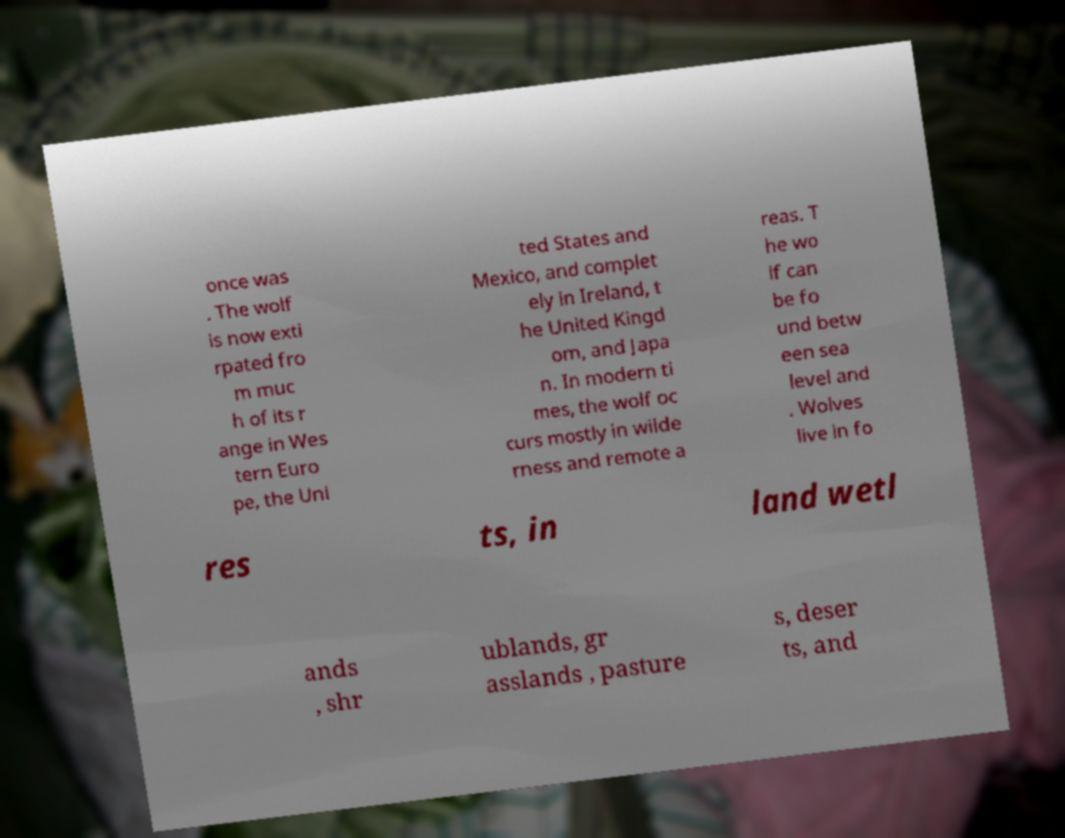Please read and relay the text visible in this image. What does it say? once was . The wolf is now exti rpated fro m muc h of its r ange in Wes tern Euro pe, the Uni ted States and Mexico, and complet ely in Ireland, t he United Kingd om, and Japa n. In modern ti mes, the wolf oc curs mostly in wilde rness and remote a reas. T he wo lf can be fo und betw een sea level and . Wolves live in fo res ts, in land wetl ands , shr ublands, gr asslands , pasture s, deser ts, and 